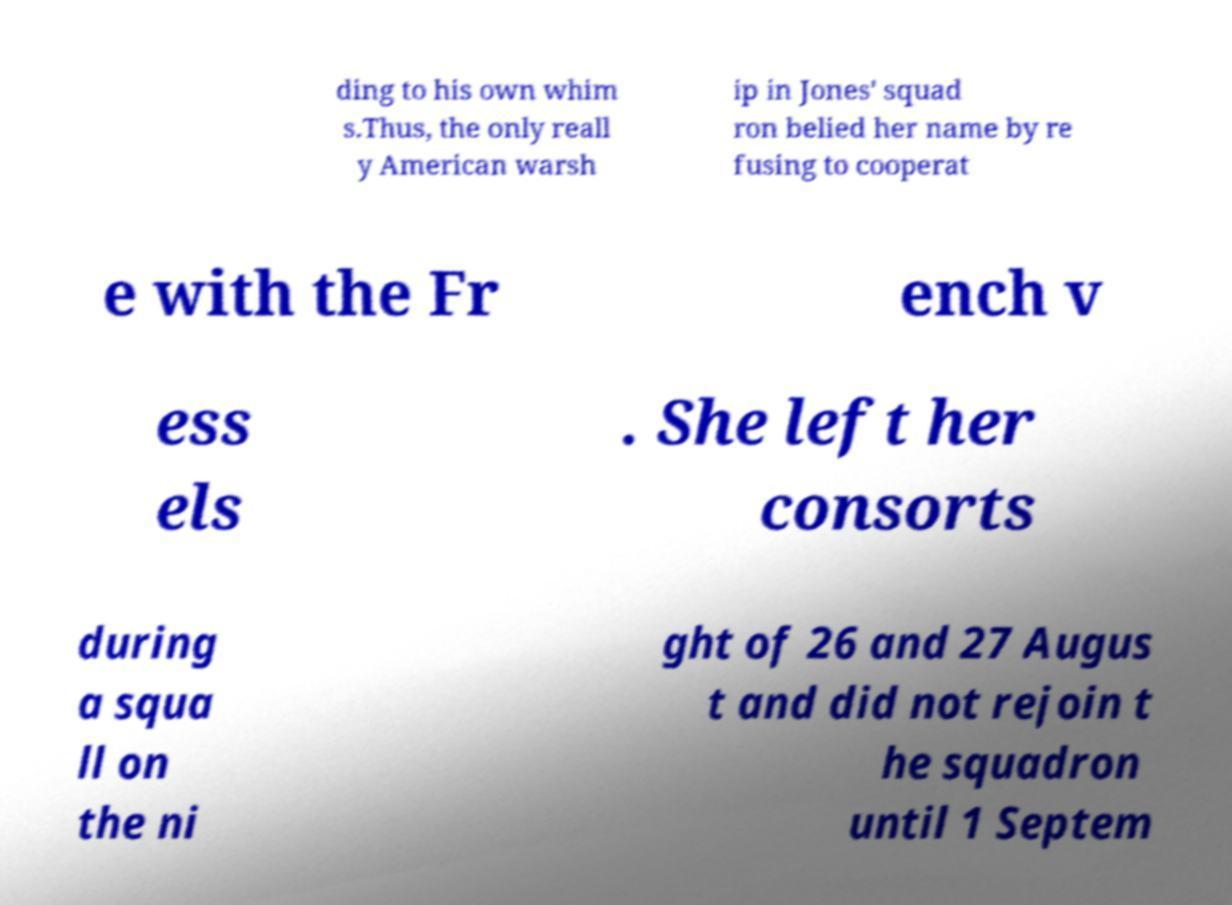Please read and relay the text visible in this image. What does it say? ding to his own whim s.Thus, the only reall y American warsh ip in Jones' squad ron belied her name by re fusing to cooperat e with the Fr ench v ess els . She left her consorts during a squa ll on the ni ght of 26 and 27 Augus t and did not rejoin t he squadron until 1 Septem 